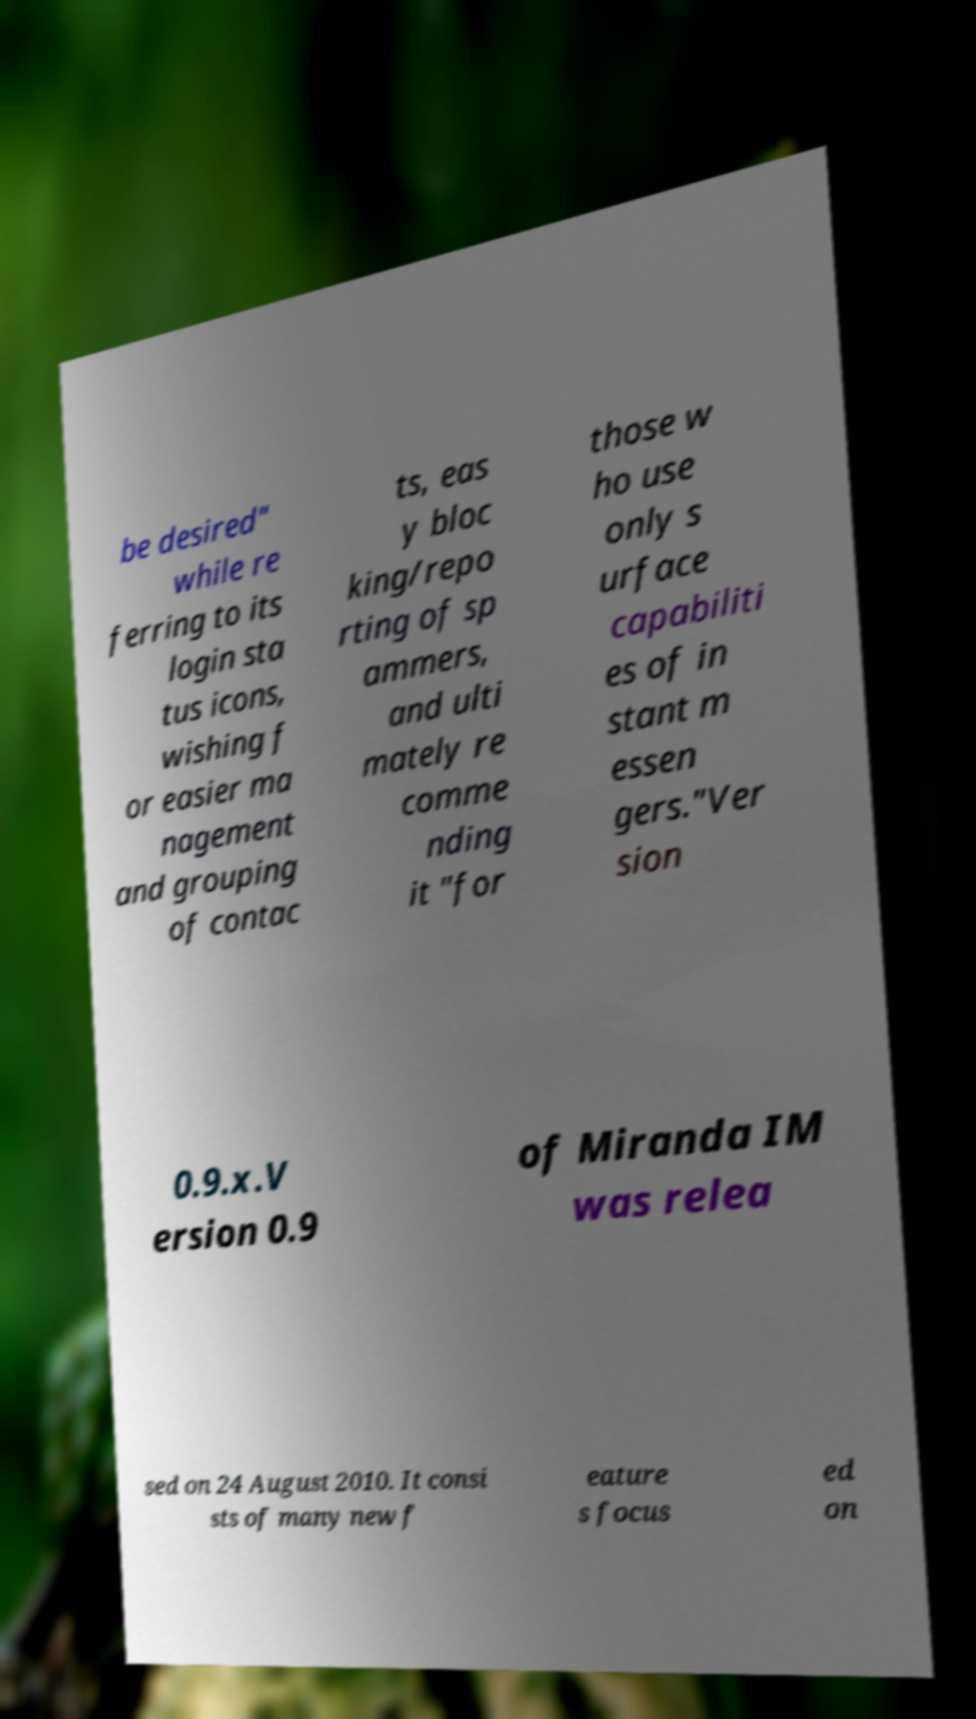Could you extract and type out the text from this image? be desired" while re ferring to its login sta tus icons, wishing f or easier ma nagement and grouping of contac ts, eas y bloc king/repo rting of sp ammers, and ulti mately re comme nding it "for those w ho use only s urface capabiliti es of in stant m essen gers."Ver sion 0.9.x.V ersion 0.9 of Miranda IM was relea sed on 24 August 2010. It consi sts of many new f eature s focus ed on 